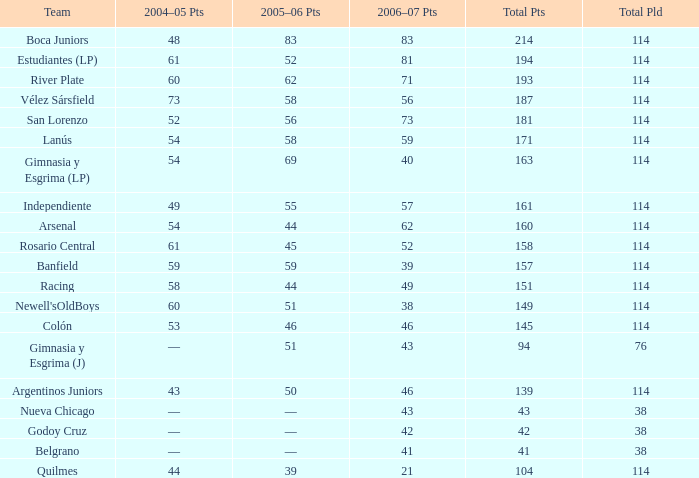What is the total number of PLD for Team Arsenal? 1.0. 